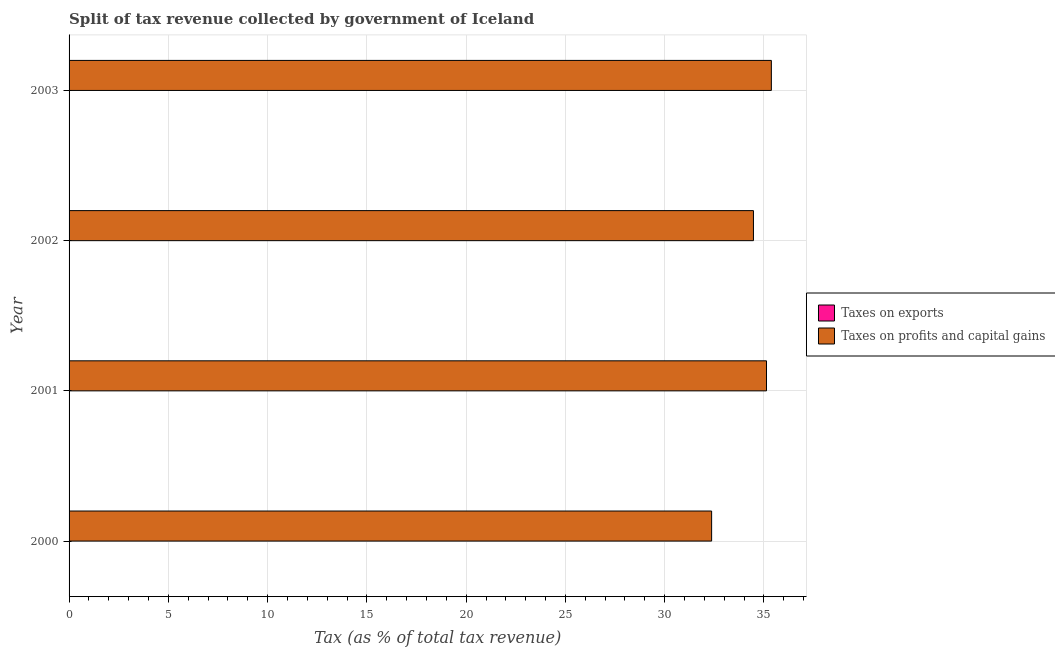How many different coloured bars are there?
Keep it short and to the point. 2. How many groups of bars are there?
Your response must be concise. 4. Are the number of bars per tick equal to the number of legend labels?
Your response must be concise. Yes. Are the number of bars on each tick of the Y-axis equal?
Make the answer very short. Yes. How many bars are there on the 4th tick from the bottom?
Ensure brevity in your answer.  2. What is the label of the 3rd group of bars from the top?
Provide a short and direct response. 2001. What is the percentage of revenue obtained from taxes on exports in 2002?
Offer a very short reply. 0. Across all years, what is the maximum percentage of revenue obtained from taxes on profits and capital gains?
Provide a succinct answer. 35.37. Across all years, what is the minimum percentage of revenue obtained from taxes on profits and capital gains?
Make the answer very short. 32.36. What is the total percentage of revenue obtained from taxes on exports in the graph?
Provide a short and direct response. 0.01. What is the difference between the percentage of revenue obtained from taxes on profits and capital gains in 2002 and that in 2003?
Ensure brevity in your answer.  -0.9. What is the difference between the percentage of revenue obtained from taxes on exports in 2000 and the percentage of revenue obtained from taxes on profits and capital gains in 2001?
Offer a terse response. -35.12. What is the average percentage of revenue obtained from taxes on exports per year?
Keep it short and to the point. 0. In the year 2000, what is the difference between the percentage of revenue obtained from taxes on exports and percentage of revenue obtained from taxes on profits and capital gains?
Your answer should be compact. -32.36. In how many years, is the percentage of revenue obtained from taxes on profits and capital gains greater than 29 %?
Keep it short and to the point. 4. What is the ratio of the percentage of revenue obtained from taxes on exports in 2000 to that in 2002?
Ensure brevity in your answer.  20.43. Is the percentage of revenue obtained from taxes on profits and capital gains in 2001 less than that in 2002?
Make the answer very short. No. What is the difference between the highest and the second highest percentage of revenue obtained from taxes on exports?
Provide a succinct answer. 0.01. What is the difference between the highest and the lowest percentage of revenue obtained from taxes on profits and capital gains?
Your answer should be compact. 3.01. In how many years, is the percentage of revenue obtained from taxes on profits and capital gains greater than the average percentage of revenue obtained from taxes on profits and capital gains taken over all years?
Offer a terse response. 3. What does the 2nd bar from the top in 2002 represents?
Keep it short and to the point. Taxes on exports. What does the 1st bar from the bottom in 2000 represents?
Keep it short and to the point. Taxes on exports. Does the graph contain any zero values?
Provide a succinct answer. No. Does the graph contain grids?
Keep it short and to the point. Yes. How are the legend labels stacked?
Provide a short and direct response. Vertical. What is the title of the graph?
Your response must be concise. Split of tax revenue collected by government of Iceland. Does "Young" appear as one of the legend labels in the graph?
Make the answer very short. No. What is the label or title of the X-axis?
Make the answer very short. Tax (as % of total tax revenue). What is the Tax (as % of total tax revenue) in Taxes on exports in 2000?
Provide a short and direct response. 0.01. What is the Tax (as % of total tax revenue) of Taxes on profits and capital gains in 2000?
Offer a very short reply. 32.36. What is the Tax (as % of total tax revenue) of Taxes on exports in 2001?
Ensure brevity in your answer.  0. What is the Tax (as % of total tax revenue) of Taxes on profits and capital gains in 2001?
Provide a short and direct response. 35.13. What is the Tax (as % of total tax revenue) of Taxes on exports in 2002?
Provide a short and direct response. 0. What is the Tax (as % of total tax revenue) of Taxes on profits and capital gains in 2002?
Keep it short and to the point. 34.47. What is the Tax (as % of total tax revenue) of Taxes on exports in 2003?
Your answer should be very brief. 0. What is the Tax (as % of total tax revenue) in Taxes on profits and capital gains in 2003?
Provide a succinct answer. 35.37. Across all years, what is the maximum Tax (as % of total tax revenue) of Taxes on exports?
Your response must be concise. 0.01. Across all years, what is the maximum Tax (as % of total tax revenue) of Taxes on profits and capital gains?
Keep it short and to the point. 35.37. Across all years, what is the minimum Tax (as % of total tax revenue) in Taxes on exports?
Provide a short and direct response. 0. Across all years, what is the minimum Tax (as % of total tax revenue) in Taxes on profits and capital gains?
Give a very brief answer. 32.36. What is the total Tax (as % of total tax revenue) in Taxes on exports in the graph?
Make the answer very short. 0.01. What is the total Tax (as % of total tax revenue) of Taxes on profits and capital gains in the graph?
Ensure brevity in your answer.  137.33. What is the difference between the Tax (as % of total tax revenue) of Taxes on exports in 2000 and that in 2001?
Keep it short and to the point. 0.01. What is the difference between the Tax (as % of total tax revenue) in Taxes on profits and capital gains in 2000 and that in 2001?
Provide a short and direct response. -2.76. What is the difference between the Tax (as % of total tax revenue) of Taxes on exports in 2000 and that in 2002?
Give a very brief answer. 0.01. What is the difference between the Tax (as % of total tax revenue) of Taxes on profits and capital gains in 2000 and that in 2002?
Ensure brevity in your answer.  -2.11. What is the difference between the Tax (as % of total tax revenue) in Taxes on exports in 2000 and that in 2003?
Make the answer very short. 0.01. What is the difference between the Tax (as % of total tax revenue) of Taxes on profits and capital gains in 2000 and that in 2003?
Provide a succinct answer. -3.01. What is the difference between the Tax (as % of total tax revenue) in Taxes on profits and capital gains in 2001 and that in 2002?
Offer a very short reply. 0.66. What is the difference between the Tax (as % of total tax revenue) in Taxes on exports in 2001 and that in 2003?
Your response must be concise. -0. What is the difference between the Tax (as % of total tax revenue) of Taxes on profits and capital gains in 2001 and that in 2003?
Offer a very short reply. -0.24. What is the difference between the Tax (as % of total tax revenue) of Taxes on exports in 2002 and that in 2003?
Offer a terse response. -0. What is the difference between the Tax (as % of total tax revenue) of Taxes on profits and capital gains in 2002 and that in 2003?
Keep it short and to the point. -0.9. What is the difference between the Tax (as % of total tax revenue) of Taxes on exports in 2000 and the Tax (as % of total tax revenue) of Taxes on profits and capital gains in 2001?
Your answer should be very brief. -35.12. What is the difference between the Tax (as % of total tax revenue) in Taxes on exports in 2000 and the Tax (as % of total tax revenue) in Taxes on profits and capital gains in 2002?
Your response must be concise. -34.46. What is the difference between the Tax (as % of total tax revenue) in Taxes on exports in 2000 and the Tax (as % of total tax revenue) in Taxes on profits and capital gains in 2003?
Your answer should be compact. -35.37. What is the difference between the Tax (as % of total tax revenue) in Taxes on exports in 2001 and the Tax (as % of total tax revenue) in Taxes on profits and capital gains in 2002?
Offer a very short reply. -34.47. What is the difference between the Tax (as % of total tax revenue) in Taxes on exports in 2001 and the Tax (as % of total tax revenue) in Taxes on profits and capital gains in 2003?
Provide a short and direct response. -35.37. What is the difference between the Tax (as % of total tax revenue) of Taxes on exports in 2002 and the Tax (as % of total tax revenue) of Taxes on profits and capital gains in 2003?
Keep it short and to the point. -35.37. What is the average Tax (as % of total tax revenue) of Taxes on exports per year?
Offer a terse response. 0. What is the average Tax (as % of total tax revenue) in Taxes on profits and capital gains per year?
Provide a short and direct response. 34.33. In the year 2000, what is the difference between the Tax (as % of total tax revenue) of Taxes on exports and Tax (as % of total tax revenue) of Taxes on profits and capital gains?
Make the answer very short. -32.36. In the year 2001, what is the difference between the Tax (as % of total tax revenue) in Taxes on exports and Tax (as % of total tax revenue) in Taxes on profits and capital gains?
Keep it short and to the point. -35.13. In the year 2002, what is the difference between the Tax (as % of total tax revenue) of Taxes on exports and Tax (as % of total tax revenue) of Taxes on profits and capital gains?
Provide a succinct answer. -34.47. In the year 2003, what is the difference between the Tax (as % of total tax revenue) of Taxes on exports and Tax (as % of total tax revenue) of Taxes on profits and capital gains?
Provide a succinct answer. -35.37. What is the ratio of the Tax (as % of total tax revenue) of Taxes on exports in 2000 to that in 2001?
Keep it short and to the point. 20.47. What is the ratio of the Tax (as % of total tax revenue) of Taxes on profits and capital gains in 2000 to that in 2001?
Offer a terse response. 0.92. What is the ratio of the Tax (as % of total tax revenue) in Taxes on exports in 2000 to that in 2002?
Ensure brevity in your answer.  20.43. What is the ratio of the Tax (as % of total tax revenue) in Taxes on profits and capital gains in 2000 to that in 2002?
Your response must be concise. 0.94. What is the ratio of the Tax (as % of total tax revenue) in Taxes on exports in 2000 to that in 2003?
Your response must be concise. 19.29. What is the ratio of the Tax (as % of total tax revenue) of Taxes on profits and capital gains in 2000 to that in 2003?
Offer a very short reply. 0.91. What is the ratio of the Tax (as % of total tax revenue) of Taxes on exports in 2001 to that in 2002?
Offer a very short reply. 1. What is the ratio of the Tax (as % of total tax revenue) in Taxes on profits and capital gains in 2001 to that in 2002?
Your response must be concise. 1.02. What is the ratio of the Tax (as % of total tax revenue) in Taxes on exports in 2001 to that in 2003?
Offer a very short reply. 0.94. What is the ratio of the Tax (as % of total tax revenue) in Taxes on exports in 2002 to that in 2003?
Your answer should be compact. 0.94. What is the ratio of the Tax (as % of total tax revenue) of Taxes on profits and capital gains in 2002 to that in 2003?
Your response must be concise. 0.97. What is the difference between the highest and the second highest Tax (as % of total tax revenue) in Taxes on exports?
Provide a short and direct response. 0.01. What is the difference between the highest and the second highest Tax (as % of total tax revenue) of Taxes on profits and capital gains?
Your answer should be very brief. 0.24. What is the difference between the highest and the lowest Tax (as % of total tax revenue) of Taxes on exports?
Keep it short and to the point. 0.01. What is the difference between the highest and the lowest Tax (as % of total tax revenue) in Taxes on profits and capital gains?
Your response must be concise. 3.01. 